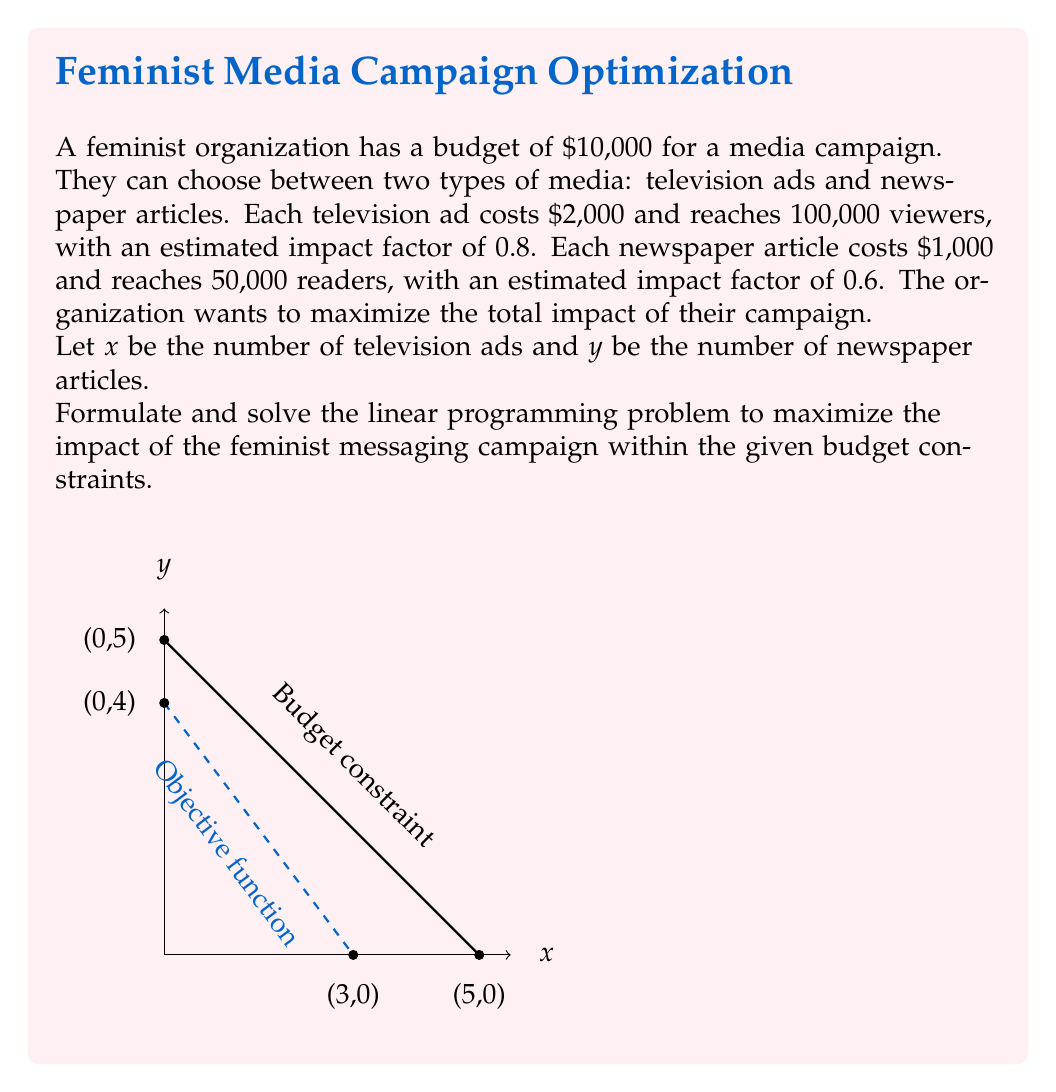Can you answer this question? Let's approach this step-by-step:

1) First, we need to formulate the objective function. The total impact is the sum of the impact from TV ads and newspaper articles:

   $$ \text{Total Impact} = 0.8 \cdot 100,000x + 0.6 \cdot 50,000y = 80,000x + 30,000y $$

2) Now, we formulate the constraints:
   
   Budget constraint: $2000x + 1000y \leq 10000$
   Non-negativity: $x \geq 0, y \geq 0$

3) Our linear programming problem is:

   Maximize $z = 80,000x + 30,000y$
   Subject to:
   $2000x + 1000y \leq 10000$
   $x \geq 0, y \geq 0$

4) To solve this, we'll use the graphical method. First, simplify the budget constraint:

   $2x + y \leq 10$

5) Plot the constraint line and the non-negativity constraints. The feasible region is the triangle bounded by $x=0$, $y=0$, and $2x+y=10$.

6) The optimal solution will be at one of the corner points of this triangle. The corner points are (0,0), (0,10), and (5,0).

7) Evaluate the objective function at these points:
   
   At (0,0): $z = 0$
   At (0,10): $z = 30,000 \cdot 10 = 300,000$
   At (5,0): $z = 80,000 \cdot 5 = 400,000$

8) The maximum value occurs at (5,0), which represents 5 TV ads and 0 newspaper articles.
Answer: 5 TV ads, 0 newspaper articles; Maximum impact: 400,000 